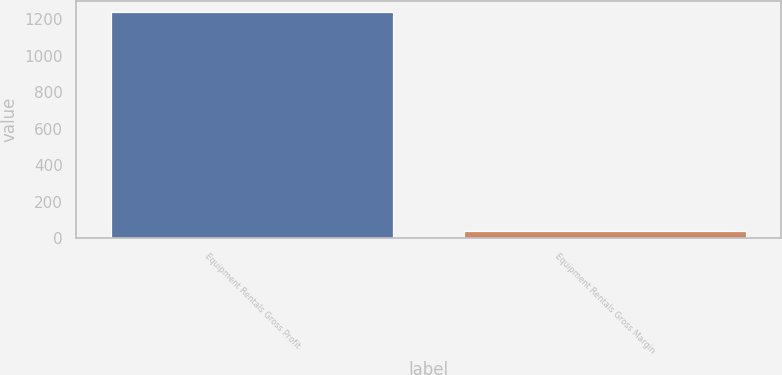<chart> <loc_0><loc_0><loc_500><loc_500><bar_chart><fcel>Equipment Rentals Gross Profit<fcel>Equipment Rentals Gross Margin<nl><fcel>1239<fcel>38.9<nl></chart> 